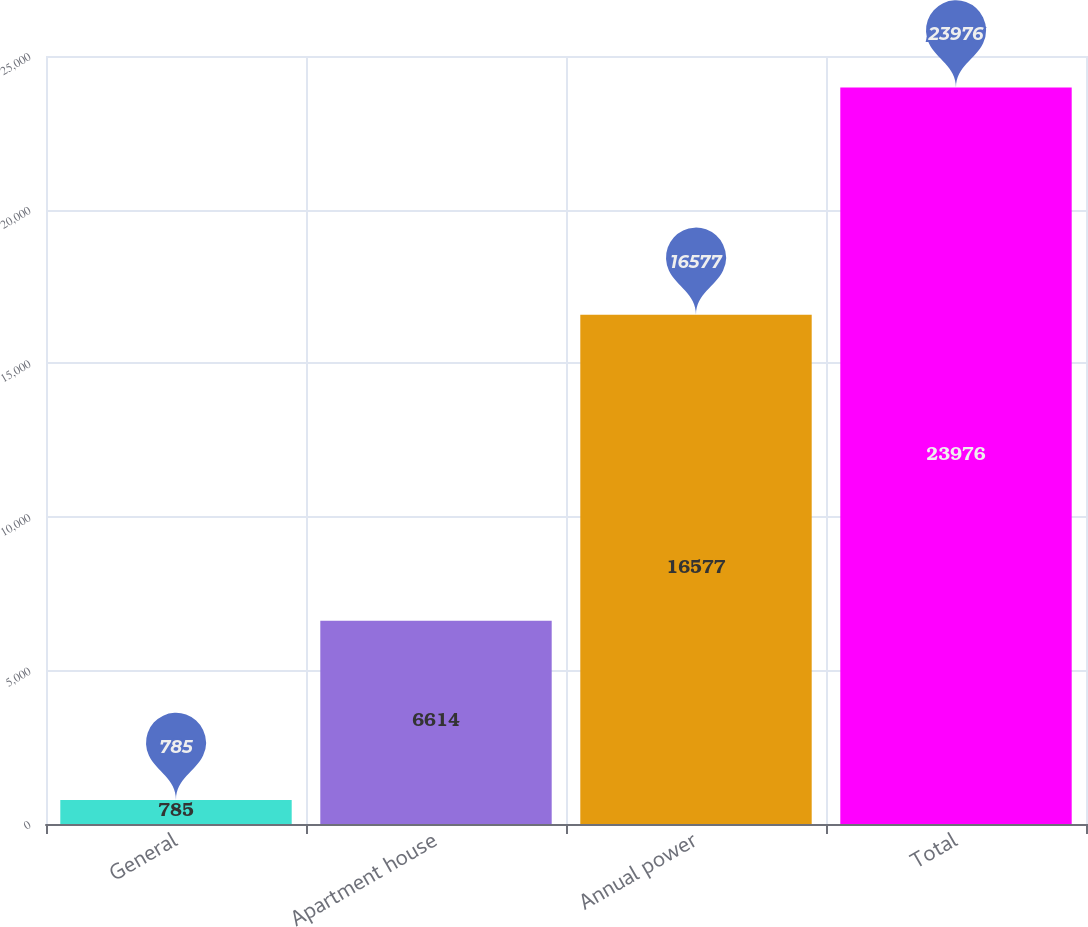Convert chart. <chart><loc_0><loc_0><loc_500><loc_500><bar_chart><fcel>General<fcel>Apartment house<fcel>Annual power<fcel>Total<nl><fcel>785<fcel>6614<fcel>16577<fcel>23976<nl></chart> 